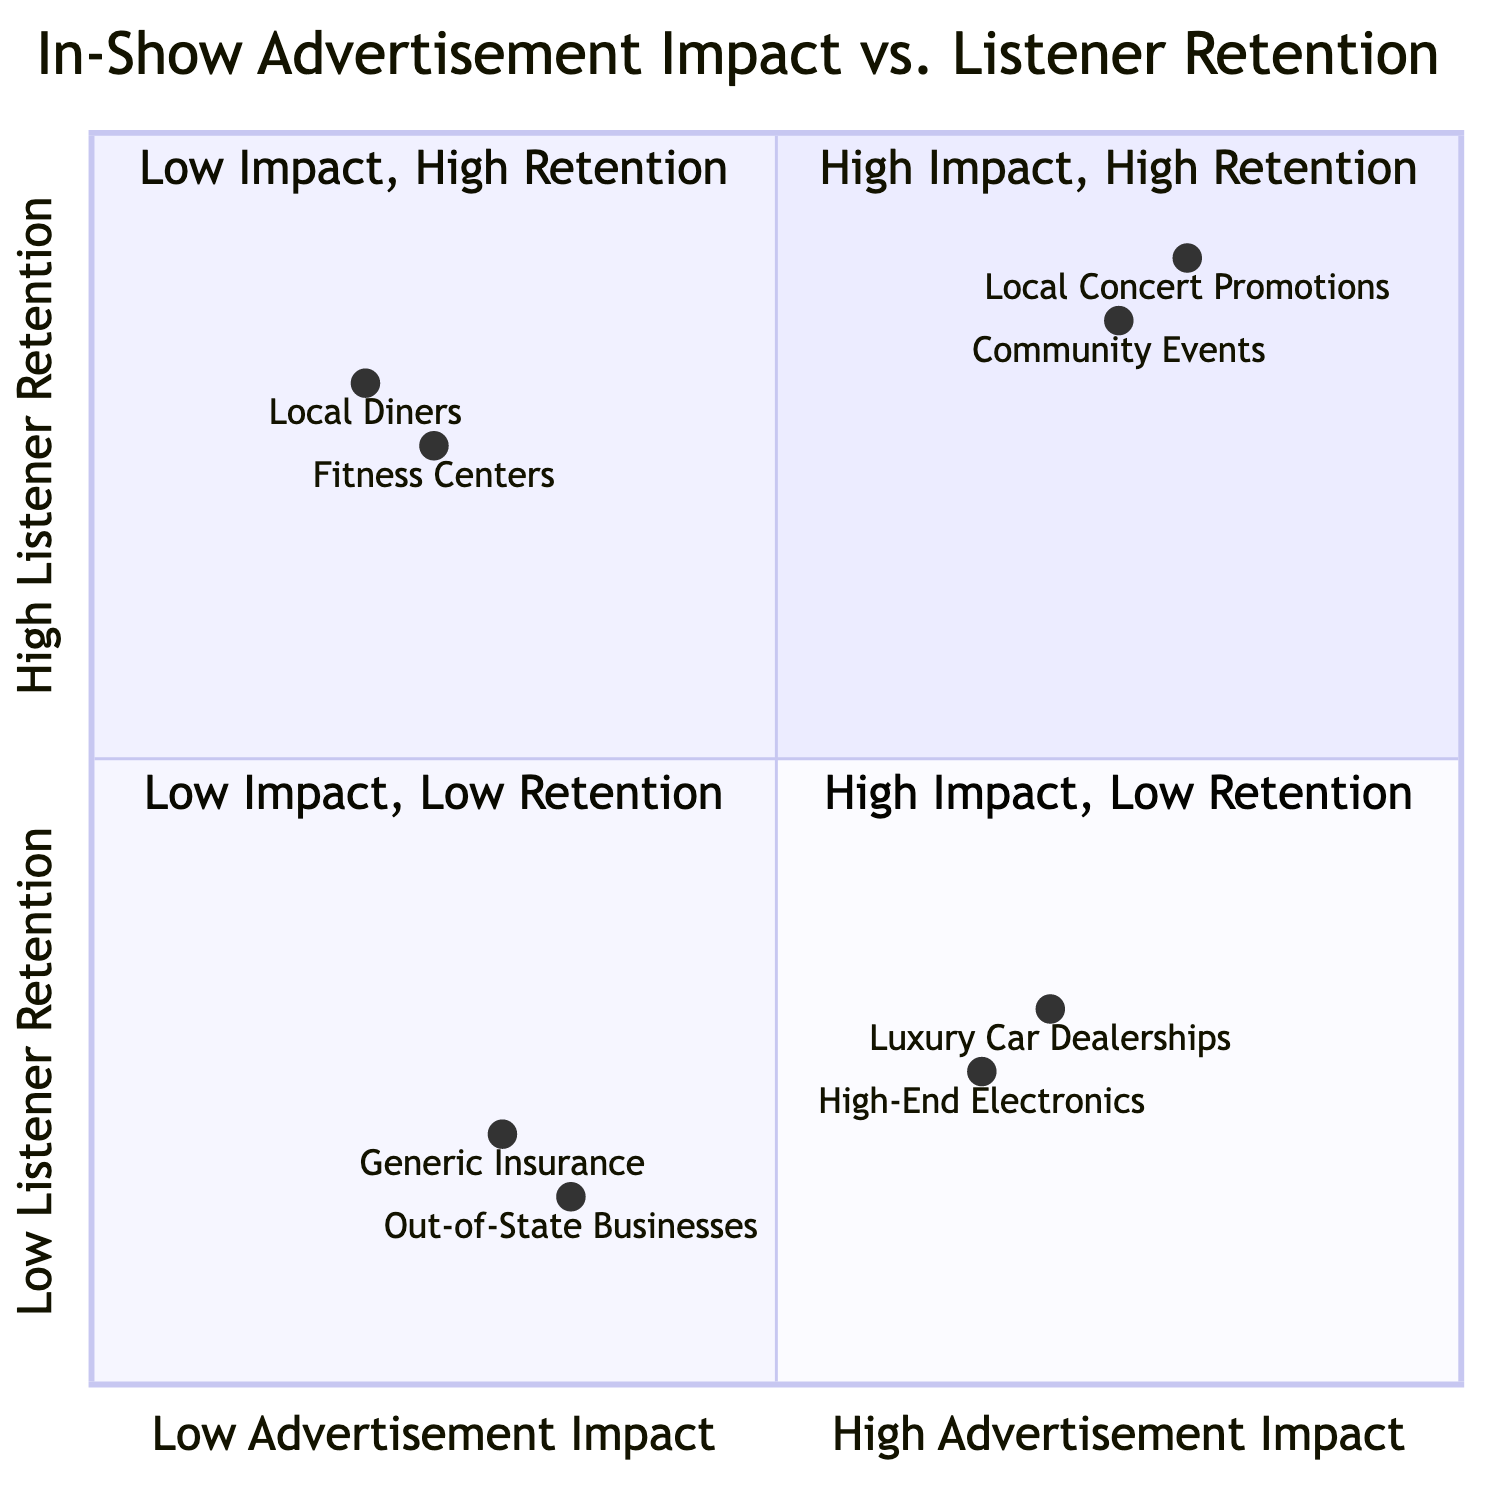What is in the High Advertisement Impact, High Listener Retention quadrant? The High Advertisement Impact, High Listener Retention quadrant contains two examples: "Local Concert Promotions" and "Community Events and Festivals". These advertisements are effective in retaining listeners while also making a significant impact.
Answer: Local Concert Promotions, Community Events and Festivals How many advertisements are located in the Low Advertisement Impact, Low Listener Retention quadrant? The Low Advertisement Impact, Low Listener Retention quadrant includes two advertisements: "Generic Insurance Companies" and "Out-of-State Businesses". Counting these, we find a total of two advertisements.
Answer: 2 Which advertisement has the highest listener retention? Among all the data provided, "Local Diners and Cafes", which is in the Low Advertisement Impact, High Listener Retention quadrant, shows a high retention value of 0.8. Comparing this to other advertisements, it retains listeners the most effectively.
Answer: Local Diners and Cafes What is the advertisement impact of High-End Electronics? The advertisement "High-End Electronics" is positioned in the High Advertisement Impact, Low Listener Retention quadrant with an impact value of 0.65. This indicates that it has a moderate impact despite low retention.
Answer: 0.65 Which quadrant contains advertisements with both high impact and low retention? The High Advertisement Impact, Low Listener Retention quadrant contains advertisements like "Luxury Car Dealerships" and "High-End Electronics". Both show a strong impact but do not retain listeners effectively.
Answer: High Advertisement Impact, Low Listener Retention What is the listener retention value for Community Events and Festivals? The advertisement "Community Events and Festivals", found in the High Advertisement Impact, High Listener Retention quadrant, has a listener retention value of 0.85. This means it retains a significant number of listeners.
Answer: 0.85 How many total quadrants are represented in the diagram? The diagram represents four quadrants, each categorizing advertisements based on their impact on advertisement and listener retention. The quadrants are distinctly divided into High/Low for both axes.
Answer: 4 Which advertisement is associated with the show segment "Listener Call-In Hours"? "Local Diners and Cafes" is linked to the show segment "Listener Call-In Hours". This segment's combination indicates its strategy in engaging listeners effectively, contributing to high retention.
Answer: Local Diners and Cafes 